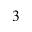Convert formula to latex. <formula><loc_0><loc_0><loc_500><loc_500>^ { 3 }</formula> 